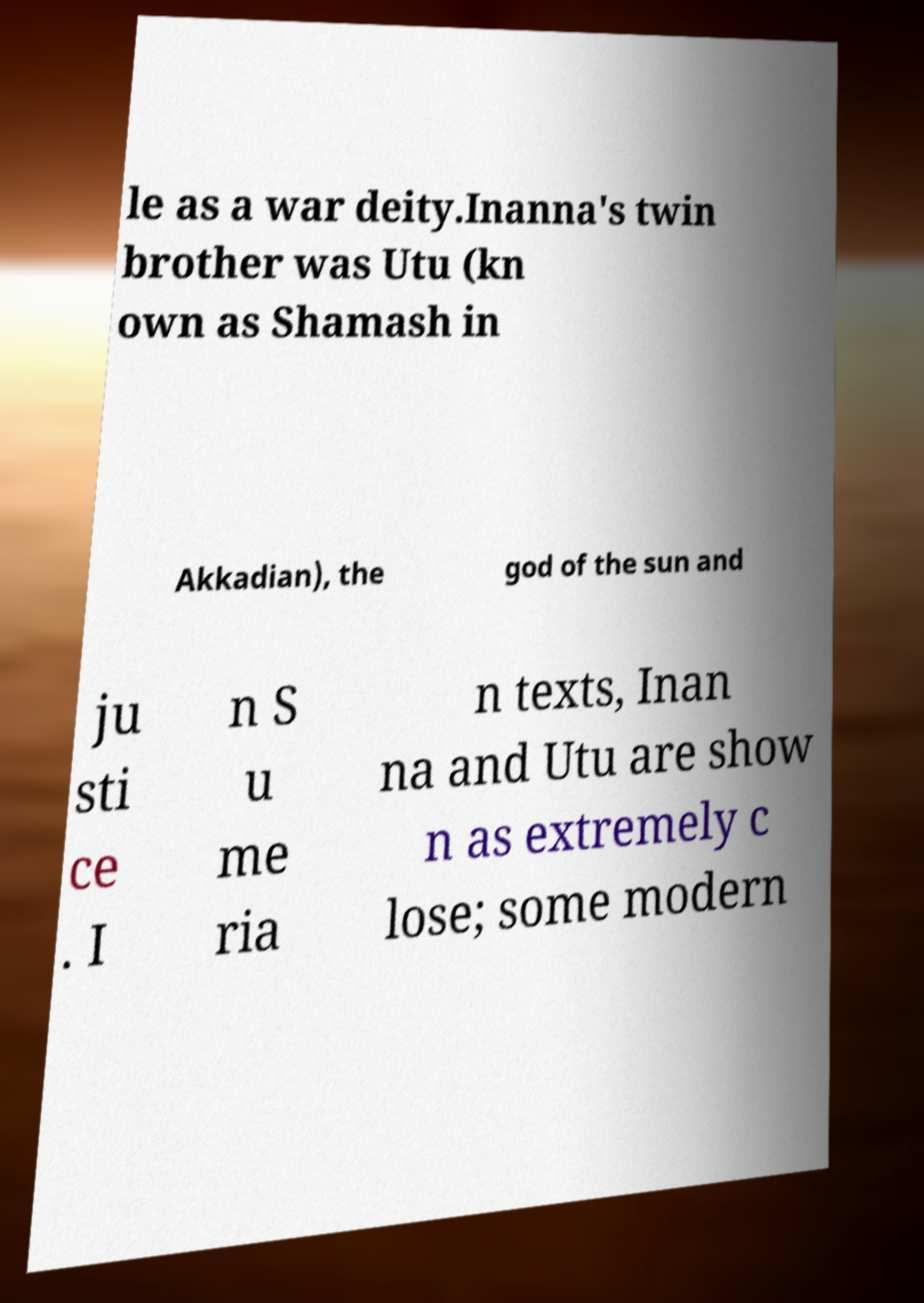Can you accurately transcribe the text from the provided image for me? le as a war deity.Inanna's twin brother was Utu (kn own as Shamash in Akkadian), the god of the sun and ju sti ce . I n S u me ria n texts, Inan na and Utu are show n as extremely c lose; some modern 